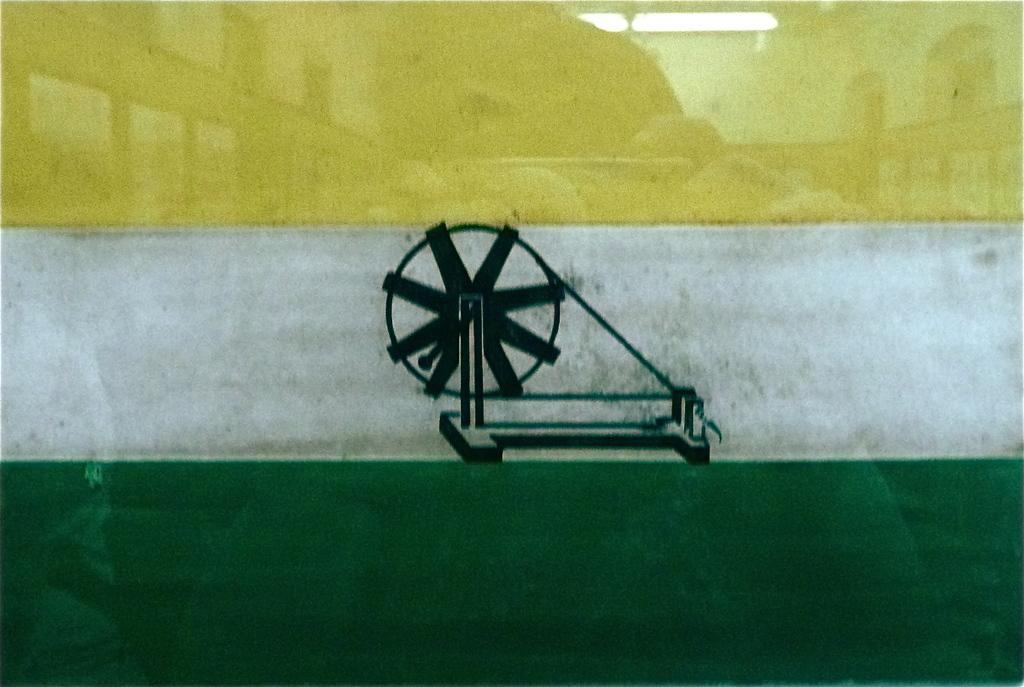What is the main subject of the image? The main subject of the image is a tricolor object. What is the design or pattern on the tricolor object? The tricolor object has a depiction of a spinning wheel. How many ladybugs can be seen on the spinning wheel in the image? There are no ladybugs present in the image; the spinning wheel is depicted on a tricolor object. 